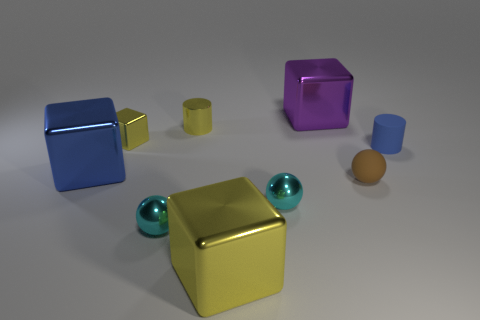Add 1 small gray rubber things. How many objects exist? 10 Subtract all cylinders. How many objects are left? 7 Subtract 0 green cubes. How many objects are left? 9 Subtract all small red objects. Subtract all tiny matte objects. How many objects are left? 7 Add 2 small brown rubber objects. How many small brown rubber objects are left? 3 Add 6 purple cubes. How many purple cubes exist? 7 